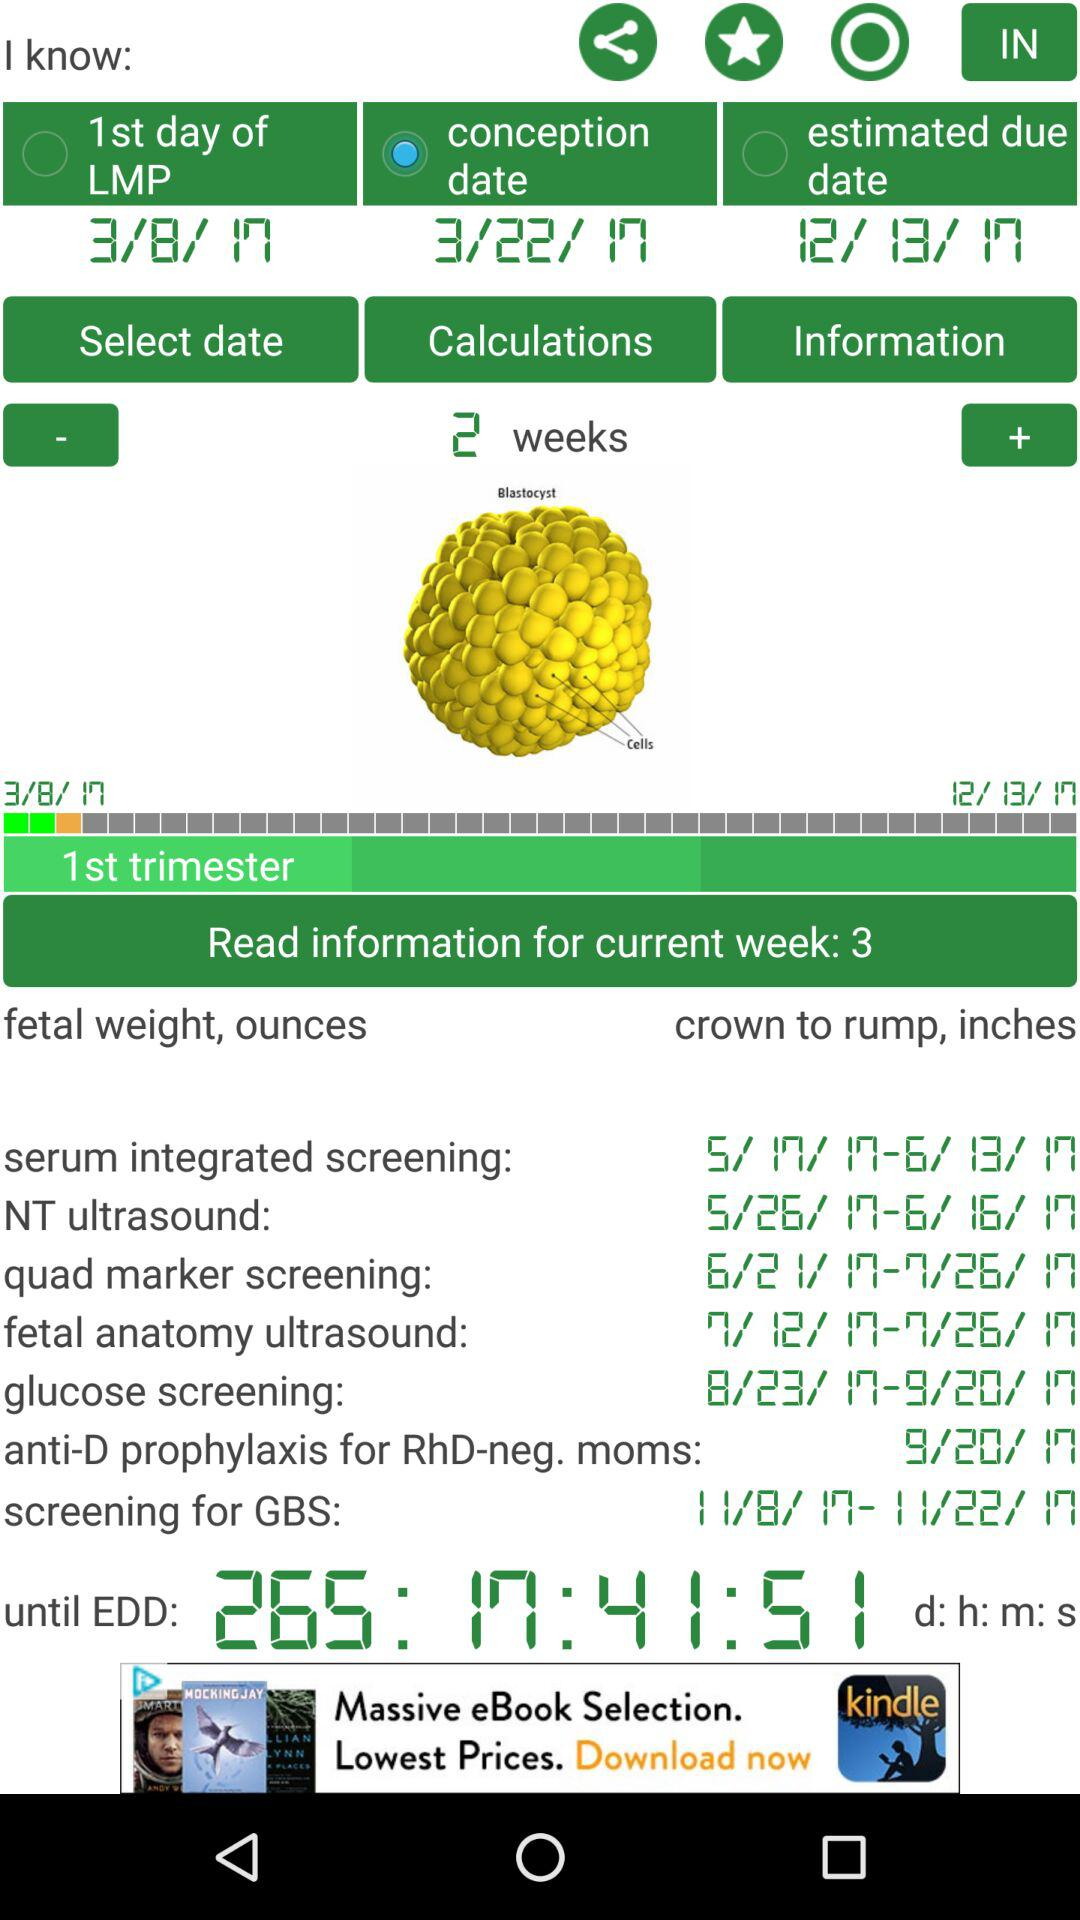What is the current trimester of pregnancy? The current trimester of pregnancy is the first. 